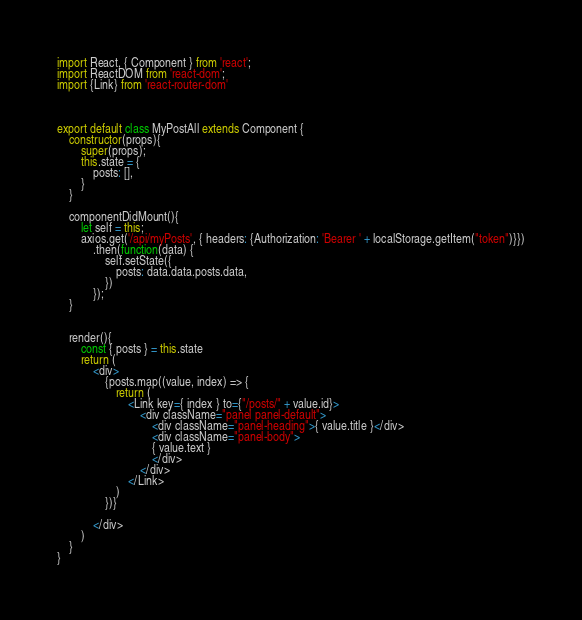Convert code to text. <code><loc_0><loc_0><loc_500><loc_500><_JavaScript_>import React, { Component } from 'react';
import ReactDOM from 'react-dom';
import {Link} from 'react-router-dom'



export default class MyPostAll extends Component {
    constructor(props){
        super(props);
        this.state = {
            posts: [],
        }
    }

    componentDidMount(){
        let self = this;
        axios.get('/api/myPosts', { headers: {Authorization: 'Bearer ' + localStorage.getItem("token")}})
            .then(function(data) {
                self.setState({
                    posts: data.data.posts.data,
                })
            });
    }


    render(){
        const { posts } = this.state
        return (
            <div>
                {posts.map((value, index) => {
                    return (
                        <Link key={ index } to={"/posts/" + value.id}>
                            <div className="panel panel-default">
                                <div className="panel-heading">{ value.title }</div>
                                <div className="panel-body">
                                { value.text }
                                </div>
                            </div>
                        </Link>
                    )
                })}
                
            </div>
        )
    }
}

</code> 